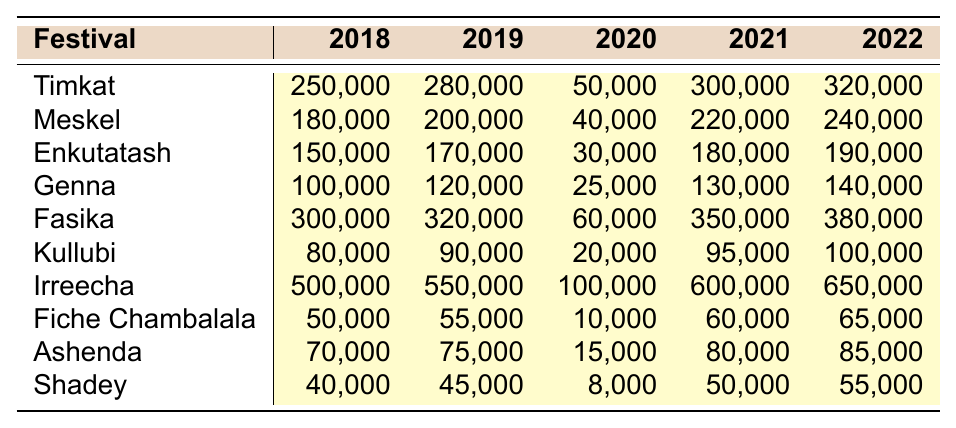What was the attendance for Timkat in 2022? The attendance for Timkat in 2022 is listed directly in the table, and it shows 320,000.
Answer: 320,000 Which festival had the highest attendance in 2019? By comparing the attendance numbers for each festival in 2019, the highest attendance is for Irreecha with 550,000 people.
Answer: Irreecha What was the overall attendance for Fasika from 2018 to 2022? The attendance for Fasika over the years is: 300,000 (2018) + 320,000 (2019) + 60,000 (2020) + 350,000 (2021) + 380,000 (2022). Adding these together gives a total of 1,410,000.
Answer: 1,410,000 Did the attendance for Genna increase from 2020 to 2021? Comparing the attendance numbers, Genna had 25,000 in 2020 and increased to 130,000 in 2021, confirming that it did increase.
Answer: Yes What is the average attendance for Ashenda from 2018 to 2022? The attendance numbers for Ashenda are: 70,000 (2018), 75,000 (2019), 15,000 (2020), 80,000 (2021), and 85,000 (2022). Summing these (70,000 + 75,000 + 15,000 + 80,000 + 85,000 = 325,000) and dividing by 5 gives an average of 65,000.
Answer: 65,000 What was the difference in attendance for Enkutatash between 2019 and 2022? The attendance for Enkutatash in 2019 is 170,000, and in 2022 it’s 190,000. The difference is calculated by subtracting 170,000 from 190,000, resulting in a difference of 20,000.
Answer: 20,000 How many festivals had an attendance of over 250,000 in 2020? Looking at the 2020 attendance, the festivals with over 250,000 are Timkat (50,000), Fasika (60,000), and Irreecha (100,000). This gives a total of 3 festivals.
Answer: 3 Which festival showed the least attendance in 2020? In 2020, Fiche Chambalala had the lowest attendance at 10,000 compared to all other festivals.
Answer: Fiche Chambalala What was the trend in attendance for Kullubi from 2018 to 2022? Reviewing the data for Kullubi, the attendance increased from 80,000 in 2018 to 100,000 in 2022, which shows a consistent upward trend over these years.
Answer: Upward trend Which festival had the lowest average attendance over all the years shown? Calculating the average attendance for each festival and comparing, Shadey has an average attendance of 45,000, which is lower than all others.
Answer: Shadey 